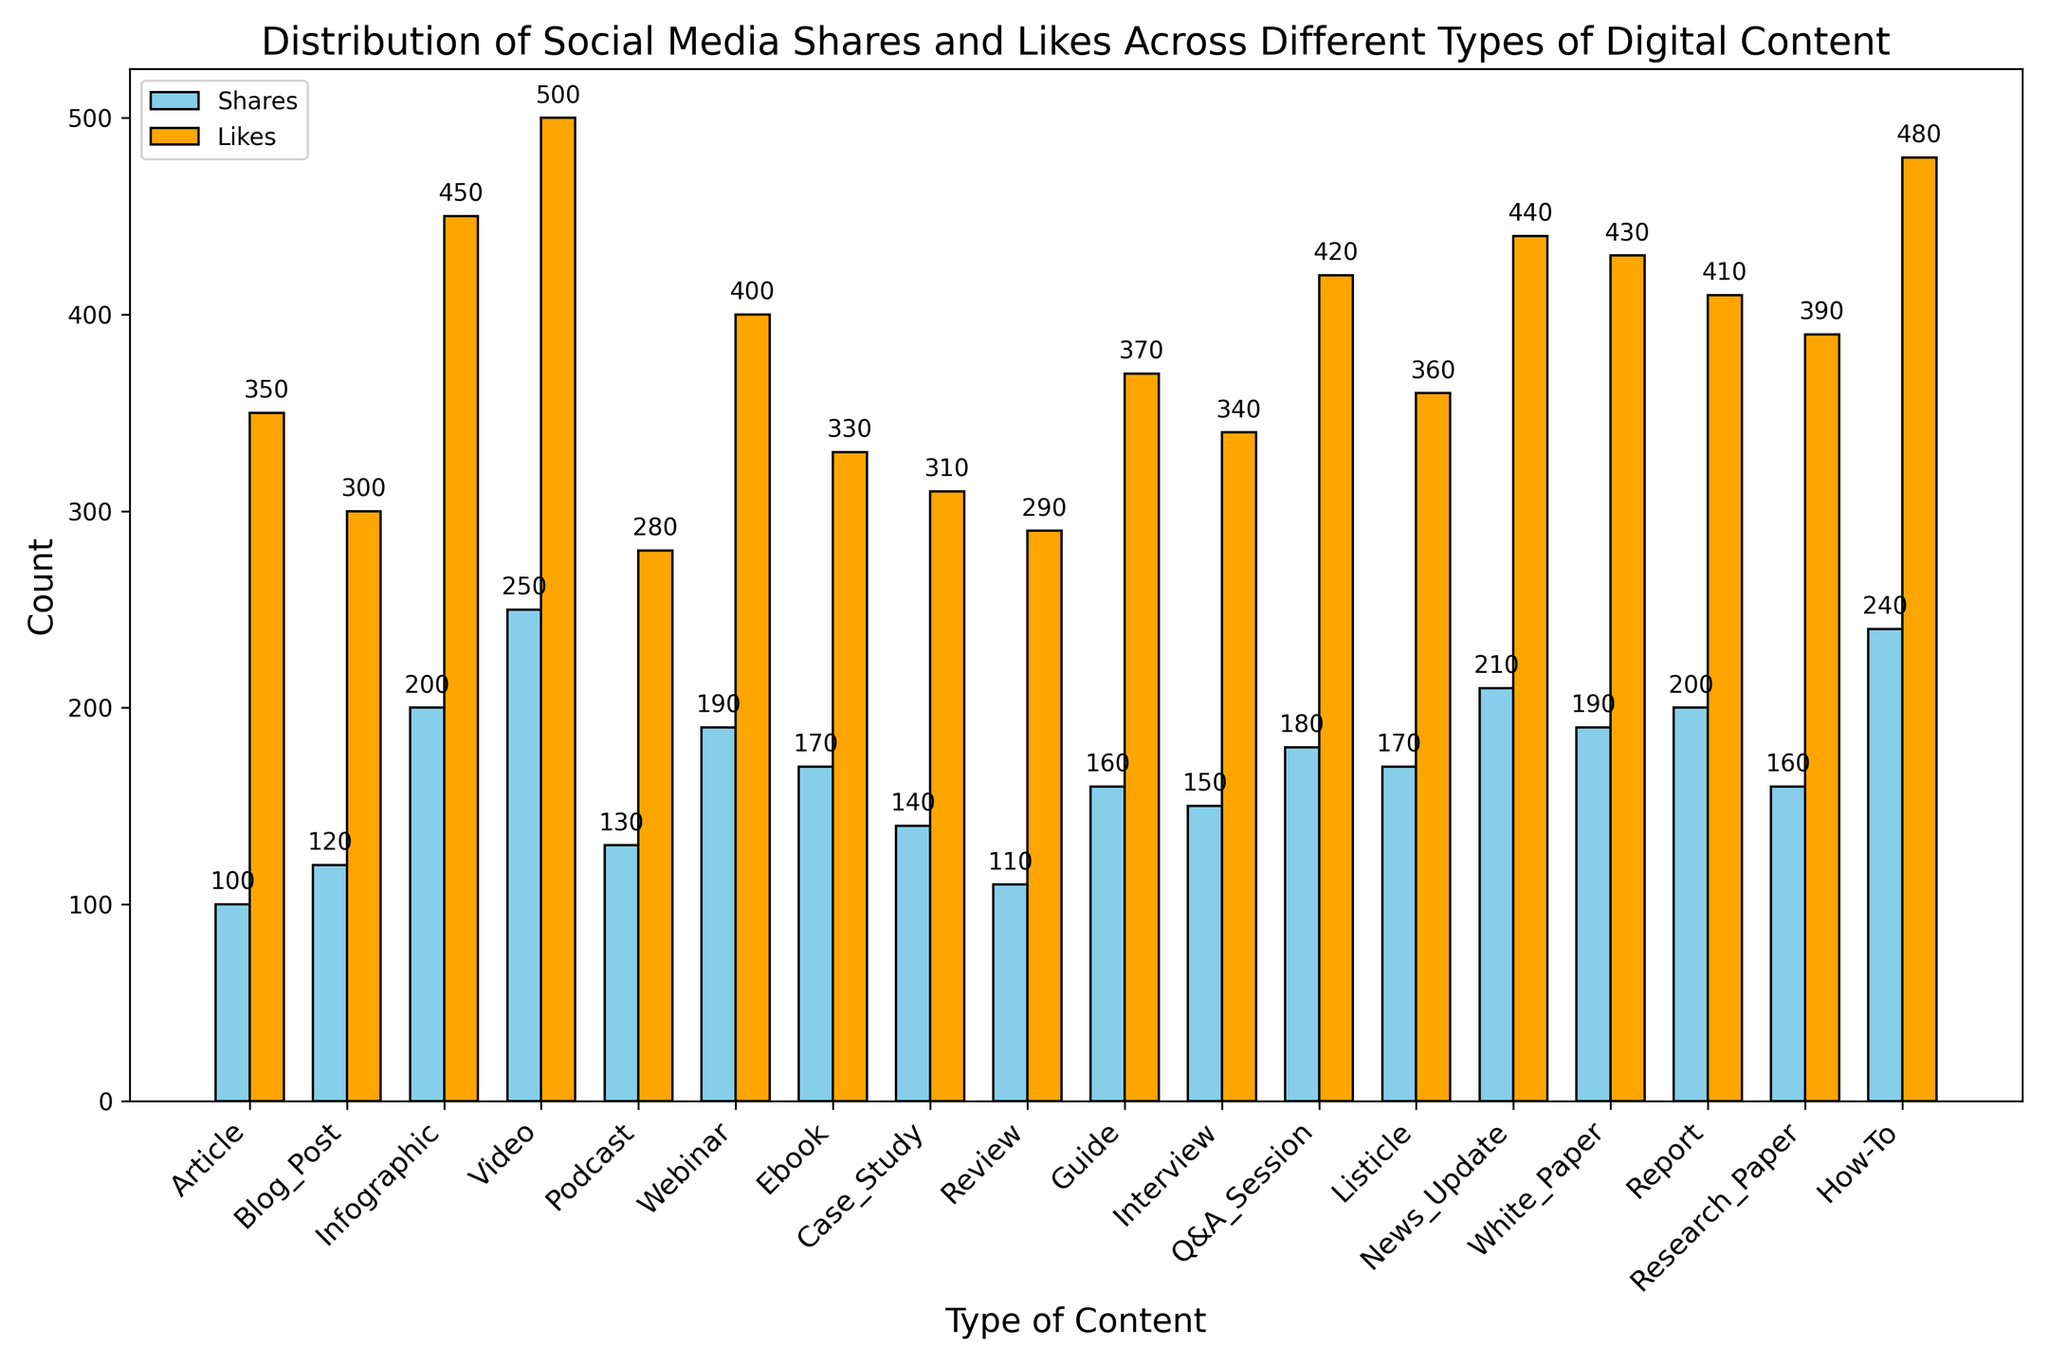How many more likes did the Video content receive compared to the Podcast content? The Video content received 500 likes, and the Podcast content received 280 likes. The difference is 500 - 280 = 220.
Answer: 220 Which type of content received the highest number of shares? By looking at the heights of the blue bars, the Video content received the highest number of shares, which is 250.
Answer: Video What is the total number of shares and likes for the Webinar content combined? The Webinar content received 190 shares and 400 likes. The total is 190 + 400 = 590.
Answer: 590 Are there any content types where the number of likes is equal to the number of shares? By comparing the heights of the blue and orange bars for each content type, none of the content types have an equal number of likes and shares.
Answer: No What is the difference in the number of shares between the Infographic and the Guide content? The Infographic content has 200 shares, and the Guide content has 160 shares. The difference is 200 - 160 = 40.
Answer: 40 Which content type has the smallest difference between the number of shares and likes? Calculating the difference for each content type and comparing them, the Podcast content has the smallest difference (300 - 280 = 20).
Answer: Podcast How many types of content have more than 300 likes? By counting the orange bars with a height greater than 300, there are 12 content types (Article, Infographic, Video, Webinar, Guide, Interview, Q&A Session, Listicle, News Update, White Paper, Report, and How-To).
Answer: 12 What is the average number of shares for the Case Study, Review, and Interview contents? Summing the shares for Case Study (140), Review (110), and Interview (150) gives 140 + 110 + 150 = 400. Dividing by 3 gives 400 / 3 ≈ 133.33.
Answer: 133.33 Which content type received the highest number of likes, and how many likes did it receive? The How-To content received the highest number of likes, with a total of 480, as seen from the height of the tallest orange bar.
Answer: How-To, 480 By what percentage does the number of shares of Video content exceed that of Blog Post content? The Video content received 250 shares and the Blog Post content received 120 shares. The percentage increase is calculated as ((250 - 120) / 120) * 100 ≈ 108.33%.
Answer: 108.33% 